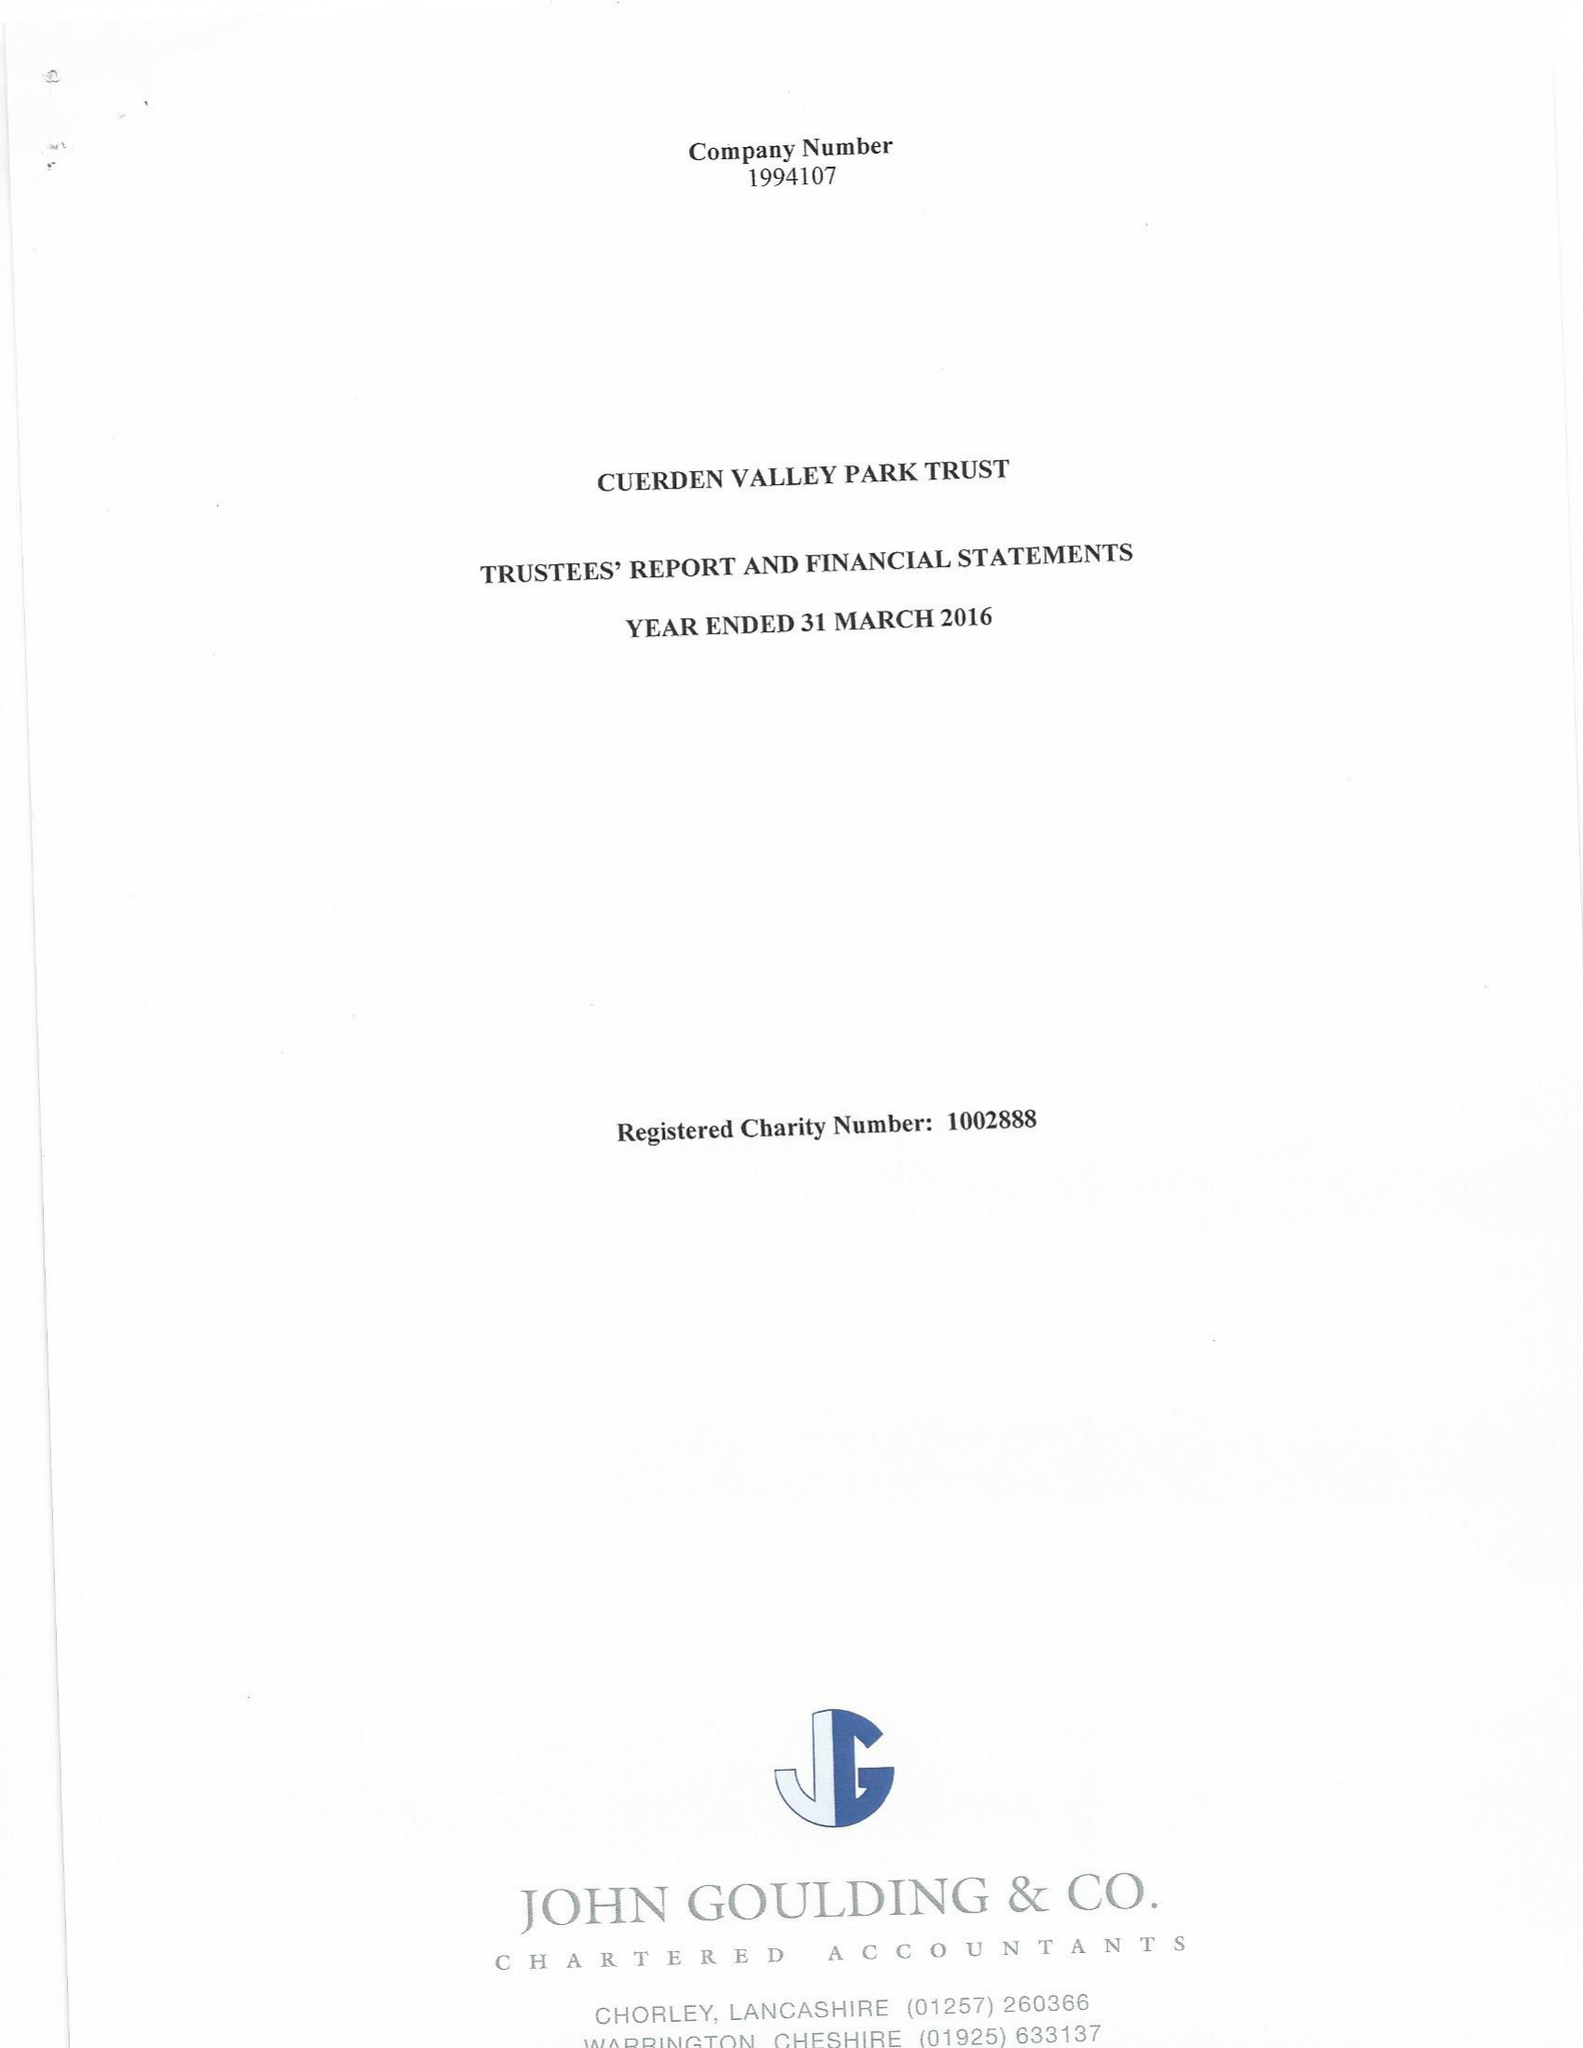What is the value for the address__post_town?
Answer the question using a single word or phrase. PRESTON 